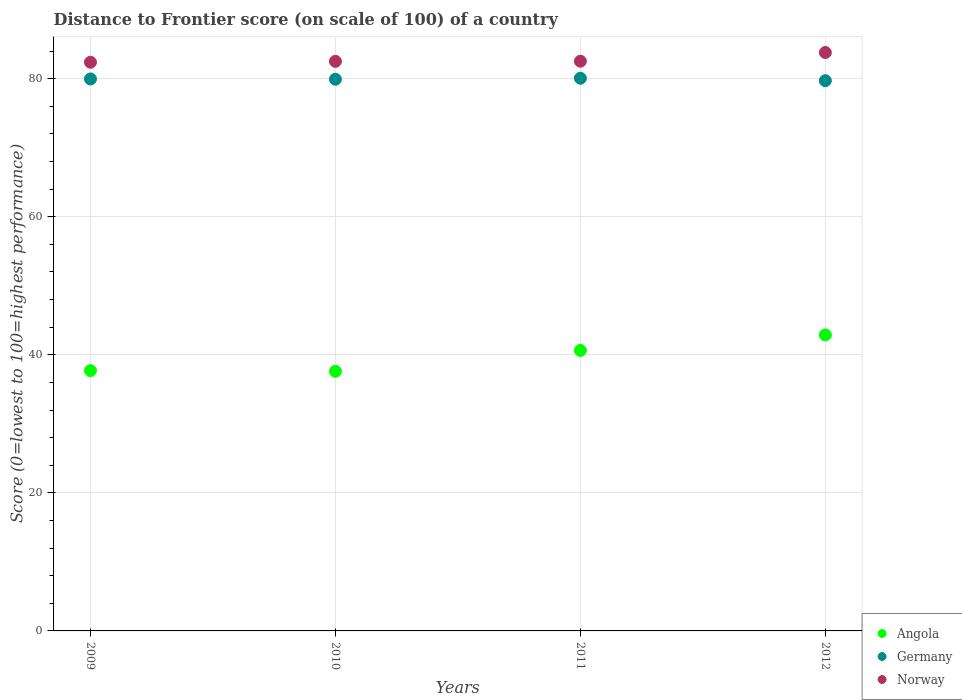Is the number of dotlines equal to the number of legend labels?
Provide a short and direct response. Yes. What is the distance to frontier score of in Germany in 2012?
Ensure brevity in your answer.  79.71. Across all years, what is the maximum distance to frontier score of in Germany?
Your answer should be very brief. 80.06. Across all years, what is the minimum distance to frontier score of in Angola?
Give a very brief answer. 37.61. In which year was the distance to frontier score of in Norway minimum?
Your answer should be compact. 2009. What is the total distance to frontier score of in Germany in the graph?
Offer a terse response. 319.65. What is the difference between the distance to frontier score of in Angola in 2010 and that in 2011?
Offer a terse response. -3.02. What is the difference between the distance to frontier score of in Germany in 2011 and the distance to frontier score of in Norway in 2009?
Your answer should be very brief. -2.32. What is the average distance to frontier score of in Norway per year?
Your answer should be very brief. 82.8. In the year 2012, what is the difference between the distance to frontier score of in Norway and distance to frontier score of in Germany?
Keep it short and to the point. 4.08. In how many years, is the distance to frontier score of in Germany greater than 80?
Your answer should be very brief. 1. What is the ratio of the distance to frontier score of in Germany in 2009 to that in 2012?
Ensure brevity in your answer.  1. Is the distance to frontier score of in Norway in 2010 less than that in 2012?
Ensure brevity in your answer.  Yes. Is the difference between the distance to frontier score of in Norway in 2010 and 2011 greater than the difference between the distance to frontier score of in Germany in 2010 and 2011?
Ensure brevity in your answer.  Yes. What is the difference between the highest and the second highest distance to frontier score of in Germany?
Make the answer very short. 0.1. What is the difference between the highest and the lowest distance to frontier score of in Norway?
Your answer should be compact. 1.41. Does the distance to frontier score of in Norway monotonically increase over the years?
Your answer should be compact. Yes. Is the distance to frontier score of in Angola strictly greater than the distance to frontier score of in Germany over the years?
Give a very brief answer. No. How many years are there in the graph?
Offer a very short reply. 4. Are the values on the major ticks of Y-axis written in scientific E-notation?
Your response must be concise. No. What is the title of the graph?
Make the answer very short. Distance to Frontier score (on scale of 100) of a country. Does "Zambia" appear as one of the legend labels in the graph?
Your answer should be very brief. No. What is the label or title of the Y-axis?
Offer a terse response. Score (0=lowest to 100=highest performance). What is the Score (0=lowest to 100=highest performance) of Angola in 2009?
Your answer should be very brief. 37.71. What is the Score (0=lowest to 100=highest performance) in Germany in 2009?
Keep it short and to the point. 79.96. What is the Score (0=lowest to 100=highest performance) of Norway in 2009?
Your answer should be very brief. 82.38. What is the Score (0=lowest to 100=highest performance) of Angola in 2010?
Make the answer very short. 37.61. What is the Score (0=lowest to 100=highest performance) of Germany in 2010?
Offer a very short reply. 79.92. What is the Score (0=lowest to 100=highest performance) of Norway in 2010?
Provide a succinct answer. 82.51. What is the Score (0=lowest to 100=highest performance) in Angola in 2011?
Ensure brevity in your answer.  40.63. What is the Score (0=lowest to 100=highest performance) in Germany in 2011?
Provide a short and direct response. 80.06. What is the Score (0=lowest to 100=highest performance) of Norway in 2011?
Ensure brevity in your answer.  82.53. What is the Score (0=lowest to 100=highest performance) of Angola in 2012?
Your response must be concise. 42.88. What is the Score (0=lowest to 100=highest performance) in Germany in 2012?
Provide a succinct answer. 79.71. What is the Score (0=lowest to 100=highest performance) of Norway in 2012?
Give a very brief answer. 83.79. Across all years, what is the maximum Score (0=lowest to 100=highest performance) of Angola?
Provide a succinct answer. 42.88. Across all years, what is the maximum Score (0=lowest to 100=highest performance) of Germany?
Offer a very short reply. 80.06. Across all years, what is the maximum Score (0=lowest to 100=highest performance) of Norway?
Give a very brief answer. 83.79. Across all years, what is the minimum Score (0=lowest to 100=highest performance) of Angola?
Give a very brief answer. 37.61. Across all years, what is the minimum Score (0=lowest to 100=highest performance) in Germany?
Offer a very short reply. 79.71. Across all years, what is the minimum Score (0=lowest to 100=highest performance) of Norway?
Give a very brief answer. 82.38. What is the total Score (0=lowest to 100=highest performance) in Angola in the graph?
Give a very brief answer. 158.83. What is the total Score (0=lowest to 100=highest performance) of Germany in the graph?
Provide a succinct answer. 319.65. What is the total Score (0=lowest to 100=highest performance) of Norway in the graph?
Give a very brief answer. 331.21. What is the difference between the Score (0=lowest to 100=highest performance) in Angola in 2009 and that in 2010?
Offer a very short reply. 0.1. What is the difference between the Score (0=lowest to 100=highest performance) in Germany in 2009 and that in 2010?
Your answer should be compact. 0.04. What is the difference between the Score (0=lowest to 100=highest performance) in Norway in 2009 and that in 2010?
Provide a succinct answer. -0.13. What is the difference between the Score (0=lowest to 100=highest performance) of Angola in 2009 and that in 2011?
Give a very brief answer. -2.92. What is the difference between the Score (0=lowest to 100=highest performance) in Norway in 2009 and that in 2011?
Provide a succinct answer. -0.15. What is the difference between the Score (0=lowest to 100=highest performance) of Angola in 2009 and that in 2012?
Your answer should be compact. -5.17. What is the difference between the Score (0=lowest to 100=highest performance) in Norway in 2009 and that in 2012?
Offer a terse response. -1.41. What is the difference between the Score (0=lowest to 100=highest performance) in Angola in 2010 and that in 2011?
Keep it short and to the point. -3.02. What is the difference between the Score (0=lowest to 100=highest performance) in Germany in 2010 and that in 2011?
Offer a terse response. -0.14. What is the difference between the Score (0=lowest to 100=highest performance) of Norway in 2010 and that in 2011?
Provide a succinct answer. -0.02. What is the difference between the Score (0=lowest to 100=highest performance) of Angola in 2010 and that in 2012?
Provide a succinct answer. -5.27. What is the difference between the Score (0=lowest to 100=highest performance) in Germany in 2010 and that in 2012?
Your answer should be very brief. 0.21. What is the difference between the Score (0=lowest to 100=highest performance) in Norway in 2010 and that in 2012?
Offer a terse response. -1.28. What is the difference between the Score (0=lowest to 100=highest performance) of Angola in 2011 and that in 2012?
Your answer should be very brief. -2.25. What is the difference between the Score (0=lowest to 100=highest performance) of Germany in 2011 and that in 2012?
Ensure brevity in your answer.  0.35. What is the difference between the Score (0=lowest to 100=highest performance) of Norway in 2011 and that in 2012?
Provide a short and direct response. -1.26. What is the difference between the Score (0=lowest to 100=highest performance) of Angola in 2009 and the Score (0=lowest to 100=highest performance) of Germany in 2010?
Your answer should be compact. -42.21. What is the difference between the Score (0=lowest to 100=highest performance) of Angola in 2009 and the Score (0=lowest to 100=highest performance) of Norway in 2010?
Your answer should be very brief. -44.8. What is the difference between the Score (0=lowest to 100=highest performance) of Germany in 2009 and the Score (0=lowest to 100=highest performance) of Norway in 2010?
Your answer should be very brief. -2.55. What is the difference between the Score (0=lowest to 100=highest performance) of Angola in 2009 and the Score (0=lowest to 100=highest performance) of Germany in 2011?
Ensure brevity in your answer.  -42.35. What is the difference between the Score (0=lowest to 100=highest performance) in Angola in 2009 and the Score (0=lowest to 100=highest performance) in Norway in 2011?
Your response must be concise. -44.82. What is the difference between the Score (0=lowest to 100=highest performance) of Germany in 2009 and the Score (0=lowest to 100=highest performance) of Norway in 2011?
Offer a very short reply. -2.57. What is the difference between the Score (0=lowest to 100=highest performance) in Angola in 2009 and the Score (0=lowest to 100=highest performance) in Germany in 2012?
Your answer should be very brief. -42. What is the difference between the Score (0=lowest to 100=highest performance) of Angola in 2009 and the Score (0=lowest to 100=highest performance) of Norway in 2012?
Your answer should be compact. -46.08. What is the difference between the Score (0=lowest to 100=highest performance) of Germany in 2009 and the Score (0=lowest to 100=highest performance) of Norway in 2012?
Make the answer very short. -3.83. What is the difference between the Score (0=lowest to 100=highest performance) of Angola in 2010 and the Score (0=lowest to 100=highest performance) of Germany in 2011?
Give a very brief answer. -42.45. What is the difference between the Score (0=lowest to 100=highest performance) in Angola in 2010 and the Score (0=lowest to 100=highest performance) in Norway in 2011?
Give a very brief answer. -44.92. What is the difference between the Score (0=lowest to 100=highest performance) in Germany in 2010 and the Score (0=lowest to 100=highest performance) in Norway in 2011?
Ensure brevity in your answer.  -2.61. What is the difference between the Score (0=lowest to 100=highest performance) of Angola in 2010 and the Score (0=lowest to 100=highest performance) of Germany in 2012?
Your answer should be very brief. -42.1. What is the difference between the Score (0=lowest to 100=highest performance) of Angola in 2010 and the Score (0=lowest to 100=highest performance) of Norway in 2012?
Give a very brief answer. -46.18. What is the difference between the Score (0=lowest to 100=highest performance) in Germany in 2010 and the Score (0=lowest to 100=highest performance) in Norway in 2012?
Provide a succinct answer. -3.87. What is the difference between the Score (0=lowest to 100=highest performance) of Angola in 2011 and the Score (0=lowest to 100=highest performance) of Germany in 2012?
Ensure brevity in your answer.  -39.08. What is the difference between the Score (0=lowest to 100=highest performance) of Angola in 2011 and the Score (0=lowest to 100=highest performance) of Norway in 2012?
Offer a very short reply. -43.16. What is the difference between the Score (0=lowest to 100=highest performance) of Germany in 2011 and the Score (0=lowest to 100=highest performance) of Norway in 2012?
Make the answer very short. -3.73. What is the average Score (0=lowest to 100=highest performance) in Angola per year?
Provide a succinct answer. 39.71. What is the average Score (0=lowest to 100=highest performance) in Germany per year?
Give a very brief answer. 79.91. What is the average Score (0=lowest to 100=highest performance) of Norway per year?
Provide a short and direct response. 82.8. In the year 2009, what is the difference between the Score (0=lowest to 100=highest performance) in Angola and Score (0=lowest to 100=highest performance) in Germany?
Make the answer very short. -42.25. In the year 2009, what is the difference between the Score (0=lowest to 100=highest performance) of Angola and Score (0=lowest to 100=highest performance) of Norway?
Make the answer very short. -44.67. In the year 2009, what is the difference between the Score (0=lowest to 100=highest performance) of Germany and Score (0=lowest to 100=highest performance) of Norway?
Your answer should be very brief. -2.42. In the year 2010, what is the difference between the Score (0=lowest to 100=highest performance) of Angola and Score (0=lowest to 100=highest performance) of Germany?
Your response must be concise. -42.31. In the year 2010, what is the difference between the Score (0=lowest to 100=highest performance) of Angola and Score (0=lowest to 100=highest performance) of Norway?
Keep it short and to the point. -44.9. In the year 2010, what is the difference between the Score (0=lowest to 100=highest performance) of Germany and Score (0=lowest to 100=highest performance) of Norway?
Provide a short and direct response. -2.59. In the year 2011, what is the difference between the Score (0=lowest to 100=highest performance) of Angola and Score (0=lowest to 100=highest performance) of Germany?
Ensure brevity in your answer.  -39.43. In the year 2011, what is the difference between the Score (0=lowest to 100=highest performance) in Angola and Score (0=lowest to 100=highest performance) in Norway?
Offer a terse response. -41.9. In the year 2011, what is the difference between the Score (0=lowest to 100=highest performance) in Germany and Score (0=lowest to 100=highest performance) in Norway?
Keep it short and to the point. -2.47. In the year 2012, what is the difference between the Score (0=lowest to 100=highest performance) in Angola and Score (0=lowest to 100=highest performance) in Germany?
Give a very brief answer. -36.83. In the year 2012, what is the difference between the Score (0=lowest to 100=highest performance) of Angola and Score (0=lowest to 100=highest performance) of Norway?
Offer a very short reply. -40.91. In the year 2012, what is the difference between the Score (0=lowest to 100=highest performance) of Germany and Score (0=lowest to 100=highest performance) of Norway?
Provide a succinct answer. -4.08. What is the ratio of the Score (0=lowest to 100=highest performance) of Angola in 2009 to that in 2010?
Make the answer very short. 1. What is the ratio of the Score (0=lowest to 100=highest performance) of Angola in 2009 to that in 2011?
Provide a succinct answer. 0.93. What is the ratio of the Score (0=lowest to 100=highest performance) of Germany in 2009 to that in 2011?
Make the answer very short. 1. What is the ratio of the Score (0=lowest to 100=highest performance) in Norway in 2009 to that in 2011?
Your response must be concise. 1. What is the ratio of the Score (0=lowest to 100=highest performance) in Angola in 2009 to that in 2012?
Give a very brief answer. 0.88. What is the ratio of the Score (0=lowest to 100=highest performance) in Norway in 2009 to that in 2012?
Give a very brief answer. 0.98. What is the ratio of the Score (0=lowest to 100=highest performance) in Angola in 2010 to that in 2011?
Make the answer very short. 0.93. What is the ratio of the Score (0=lowest to 100=highest performance) in Germany in 2010 to that in 2011?
Offer a very short reply. 1. What is the ratio of the Score (0=lowest to 100=highest performance) in Angola in 2010 to that in 2012?
Provide a succinct answer. 0.88. What is the ratio of the Score (0=lowest to 100=highest performance) in Germany in 2010 to that in 2012?
Provide a short and direct response. 1. What is the ratio of the Score (0=lowest to 100=highest performance) in Norway in 2010 to that in 2012?
Provide a short and direct response. 0.98. What is the ratio of the Score (0=lowest to 100=highest performance) in Angola in 2011 to that in 2012?
Ensure brevity in your answer.  0.95. What is the ratio of the Score (0=lowest to 100=highest performance) of Germany in 2011 to that in 2012?
Provide a succinct answer. 1. What is the difference between the highest and the second highest Score (0=lowest to 100=highest performance) of Angola?
Keep it short and to the point. 2.25. What is the difference between the highest and the second highest Score (0=lowest to 100=highest performance) of Norway?
Provide a succinct answer. 1.26. What is the difference between the highest and the lowest Score (0=lowest to 100=highest performance) of Angola?
Offer a terse response. 5.27. What is the difference between the highest and the lowest Score (0=lowest to 100=highest performance) of Norway?
Make the answer very short. 1.41. 